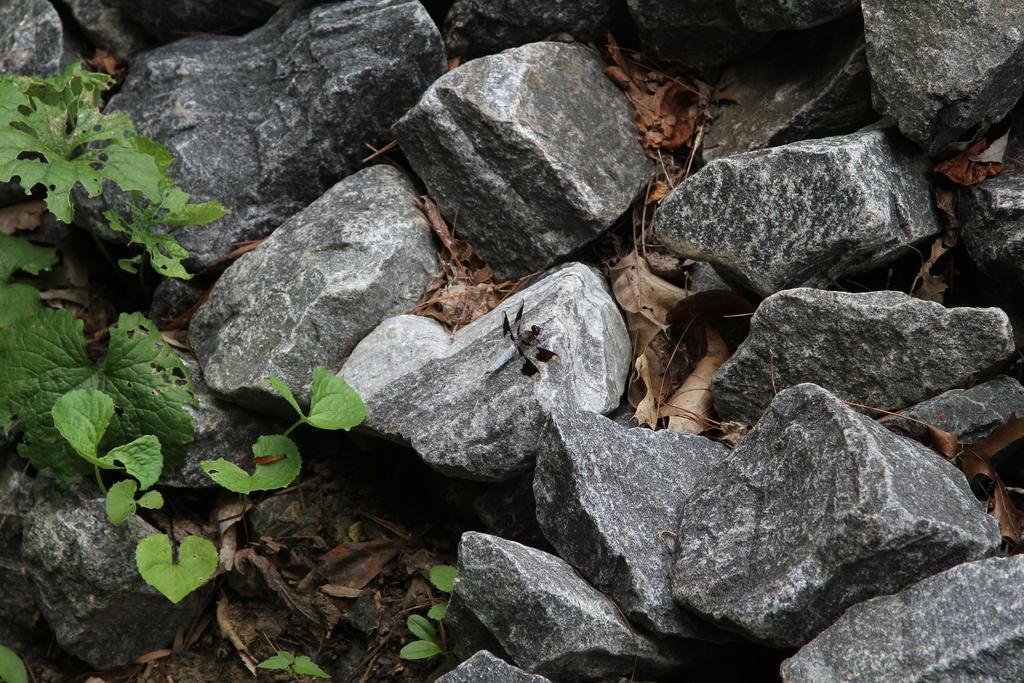What type of natural elements can be seen in the image? There are rocks, green leaves, and dry leaves in the image. Can you describe the color of the leaves in the image? The green leaves are a vibrant shade of green, while the dry leaves are brown. What might be the setting of the image based on the elements present? The image might be set in a natural environment, such as a forest or park. Where is the hydrant located in the image? There is no hydrant present in the image. What type of balls can be seen rolling on the rocks in the image? There are no balls present in the image; it only features rocks, green leaves, and dry leaves. 